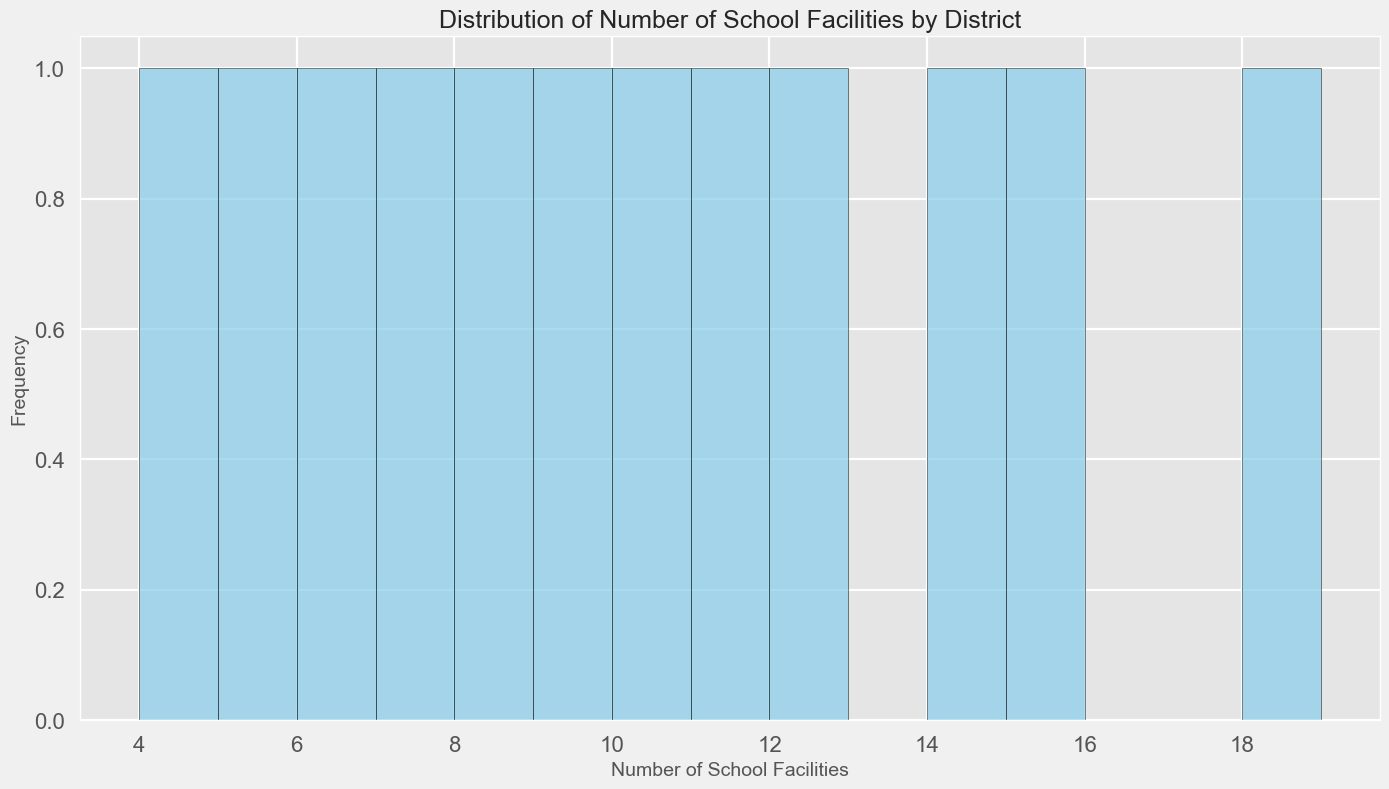What is the most common number of schools in the districts? To find the most common number of schools, look at the highest bar in the histogram, which represents the frequency of school counts.
Answer: 9 schools Which district has the fewest school facilities? Identify the lowest value on the x-axis of the histogram corresponding to the number of schools, then check which district matches this value.
Answer: Wamba Which district has the highest utilization rate, and how many schools does it have? Refer to the table of districts and examine the utilization rates. Lafia has the highest rate, and it has 18 schools.
Answer: Lafia, 18 schools How many districts have more than 10 schools? Analyze the histogram and count the bars where the number of schools is more than 10. These correspond to Districts Awe, Karu, Lafia, Nasarawa Eggon, and Toto.
Answer: 5 districts What is the range of the number of schools among the districts? Find the highest and lowest values of the number of schools in the histogram (18 and 4, respectively) and calculate the difference.
Answer: 14 schools Is the number of school facilities in Lafia more than twice that of Kokona? Lafia has 18 schools, and Kokona has 7 schools. Twice Kokona's count is 14, which is less than Lafia's count.
Answer: Yes What is the median number of school facilities among the districts? Organize the number of schools in ascending order and find the middle number. The ordered list is [4, 5, 6, 7, 8, 9, 10, 11, 12, 14, 15, 18], so the median is the average of 9 and 10.
Answer: 9.5 schools Which districts have a number of schools greater than or equal to 12? Check the histogram and identify the bars where the number of schools is greater than or equal to 12: Awe, Karu, Lafia, Nasarawa Eggon.
Answer: Awe, Karu, Lafia, Nasarawa Eggon 